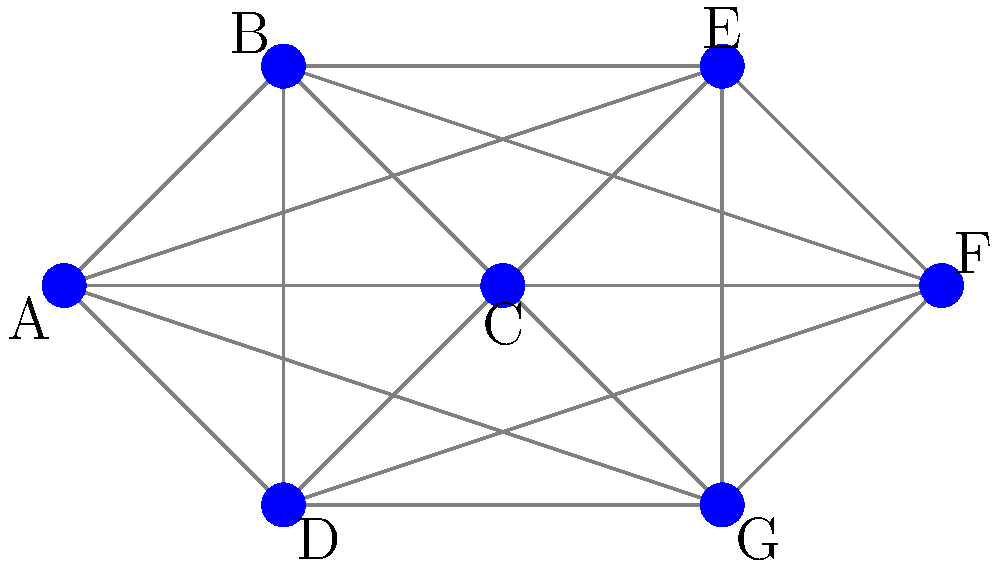In the mesh network topology shown above, if node C becomes non-operational, what is the minimum number of alternative paths that still exist between nodes A and F? To determine the minimum number of alternative paths between nodes A and F when node C is non-operational, we should follow these steps:

1. Identify all possible paths from A to F without using node C:
   a. A - B - E - F
   b. A - B - C - F (not valid as C is non-operational)
   c. A - D - G - F
   d. A - B - E - G - F
   e. A - D - B - E - F
   f. A - D - G - E - F

2. Count the number of valid paths:
   We have 5 valid paths (a, c, d, e, f) that don't include node C.

3. Determine the minimum number of alternative paths:
   The question asks for the minimum number of alternative paths, which is equivalent to the number of independent paths. In this case, we have two independent paths:
   - Path through the upper part of the network: A - B - E - F
   - Path through the lower part of the network: A - D - G - F

   These two paths do not share any nodes other than the start and end points, making them completely independent.

Therefore, the minimum number of alternative paths between A and F when node C is non-operational is 2.
Answer: 2 